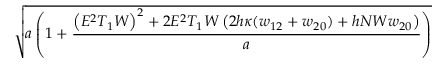<formula> <loc_0><loc_0><loc_500><loc_500>\sqrt { a \left ( 1 + \frac { \left ( E ^ { 2 } T _ { 1 } W \right ) ^ { 2 } + 2 E ^ { 2 } T _ { 1 } W \left ( 2 h \kappa ( w _ { 1 2 } + w _ { 2 0 } ) + h N W w _ { 2 0 } \right ) } { a } \right ) }</formula> 